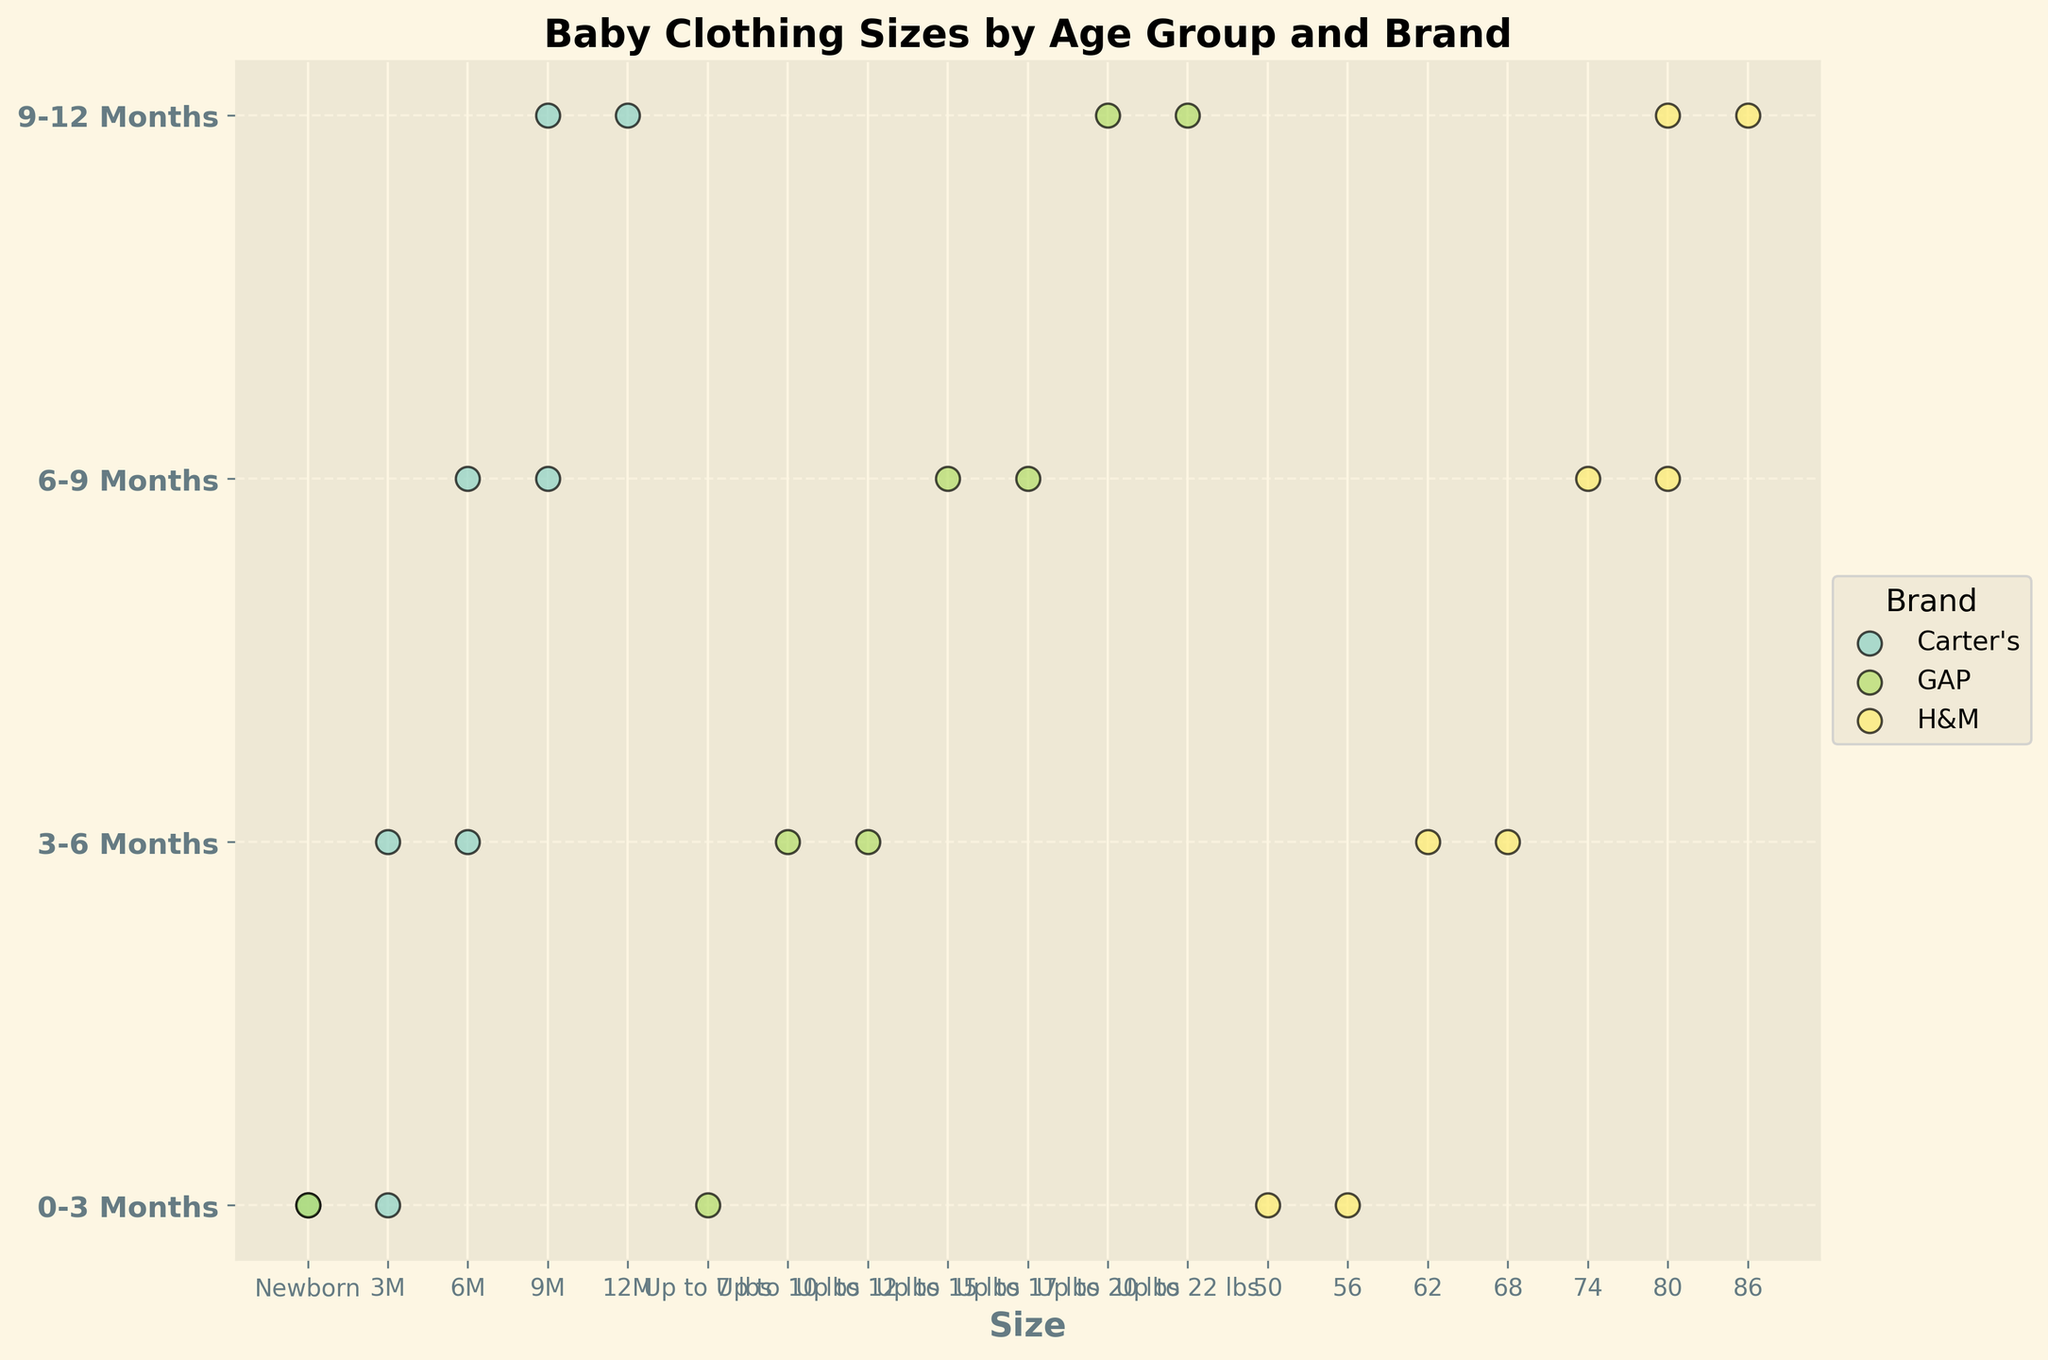What's the title of the figure? The title is a basic element of the plot and it's usually found at the top.
Answer: Baby Clothing Sizes by Age Group and Brand How many brands are represented in the figure? By looking at the legend, we can see distinct colors representing each brand. There are three brands listed.
Answer: 3 What are the age groups shown on the y-axis? The age groups can be read directly from the labels on the y-axis.
Answer: 0-3 Months, 3-6 Months, 6-9 Months, 9-12 Months Which brand has the largest range of sizes for the 6-9 Months age group? We need to identify the brand with the widest spread in sizes for 6-9 Months by checking the positions of the dots. H&M shows sizes 74 and 80, which indicates a wider range compared to the other brands.
Answer: H&M Do any brands offer the "Newborn" size? By examining the dot positions, we can see that both Carter's and GAP have dots labeled "Newborn".
Answer: Carter's, GAP Which age group has the highest number of different sizes shown on the plot? For each age group, count the number of distinct sizes indicated by the dots. Each age group shows 2 sizes for each brand. All age groups have the same number.
Answer: All age groups Does any brand repeat exactly the same sizes across different age groups? We need to check each brand to see if identical sizes appear in different age groups. Carter's repeatedly lists 3M, 6M, and 9M across 0-3, 3-6, and 6-9 months respectively.
Answer: Carter's How many sizes are available for the brand H&M in the 9-12 Months age group? By looking at the plot, we locate H&M at 9-12 Months and count the dots. H&M has sizes 80 and 86 in this age group.
Answer: 2 Which brand(s) offer sizes measured in pounds (lbs)? We need to look for sizes that are described in pounds and identify the corresponding brands. GAP offers sizes like "Up to 10 lbs" and others.
Answer: GAP 